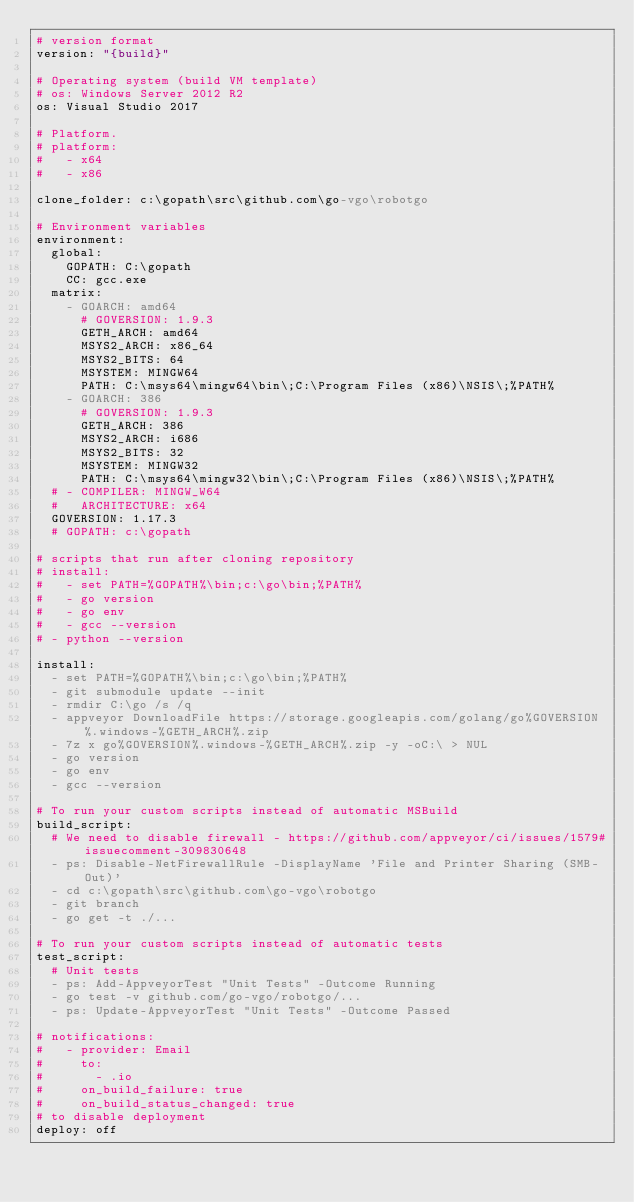<code> <loc_0><loc_0><loc_500><loc_500><_YAML_># version format
version: "{build}"

# Operating system (build VM template)
# os: Windows Server 2012 R2
os: Visual Studio 2017

# Platform.
# platform:
#   - x64
#   - x86

clone_folder: c:\gopath\src\github.com\go-vgo\robotgo

# Environment variables
environment:
  global:
    GOPATH: C:\gopath
    CC: gcc.exe
  matrix:
    - GOARCH: amd64
      # GOVERSION: 1.9.3
      GETH_ARCH: amd64
      MSYS2_ARCH: x86_64
      MSYS2_BITS: 64
      MSYSTEM: MINGW64
      PATH: C:\msys64\mingw64\bin\;C:\Program Files (x86)\NSIS\;%PATH%
    - GOARCH: 386
      # GOVERSION: 1.9.3
      GETH_ARCH: 386
      MSYS2_ARCH: i686
      MSYS2_BITS: 32
      MSYSTEM: MINGW32
      PATH: C:\msys64\mingw32\bin\;C:\Program Files (x86)\NSIS\;%PATH%
  # - COMPILER: MINGW_W64
  #   ARCHITECTURE: x64
  GOVERSION: 1.17.3
  # GOPATH: c:\gopath

# scripts that run after cloning repository
# install:
#   - set PATH=%GOPATH%\bin;c:\go\bin;%PATH%
#   - go version
#   - go env
#   - gcc --version
# - python --version

install:
  - set PATH=%GOPATH%\bin;c:\go\bin;%PATH%
  - git submodule update --init
  - rmdir C:\go /s /q
  - appveyor DownloadFile https://storage.googleapis.com/golang/go%GOVERSION%.windows-%GETH_ARCH%.zip
  - 7z x go%GOVERSION%.windows-%GETH_ARCH%.zip -y -oC:\ > NUL
  - go version
  - go env
  - gcc --version

# To run your custom scripts instead of automatic MSBuild
build_script:
  # We need to disable firewall - https://github.com/appveyor/ci/issues/1579#issuecomment-309830648
  - ps: Disable-NetFirewallRule -DisplayName 'File and Printer Sharing (SMB-Out)'
  - cd c:\gopath\src\github.com\go-vgo\robotgo
  - git branch
  - go get -t ./...

# To run your custom scripts instead of automatic tests
test_script:
  # Unit tests
  - ps: Add-AppveyorTest "Unit Tests" -Outcome Running
  - go test -v github.com/go-vgo/robotgo/...
  - ps: Update-AppveyorTest "Unit Tests" -Outcome Passed

# notifications:
#   - provider: Email
#     to:
#       - .io
#     on_build_failure: true
#     on_build_status_changed: true
# to disable deployment
deploy: off
</code> 